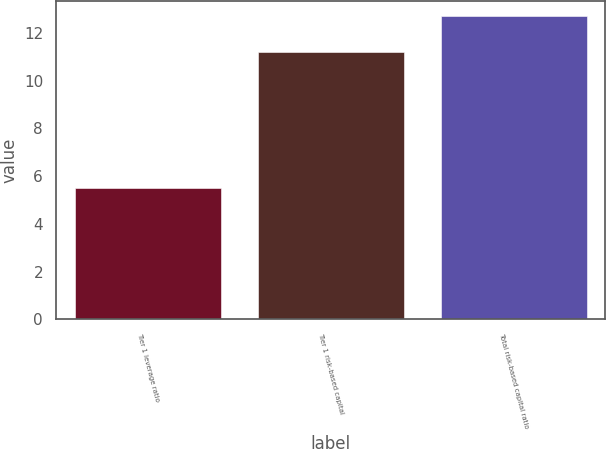Convert chart to OTSL. <chart><loc_0><loc_0><loc_500><loc_500><bar_chart><fcel>Tier 1 leverage ratio<fcel>Tier 1 risk-based capital<fcel>Total risk-based capital ratio<nl><fcel>5.5<fcel>11.2<fcel>12.7<nl></chart> 